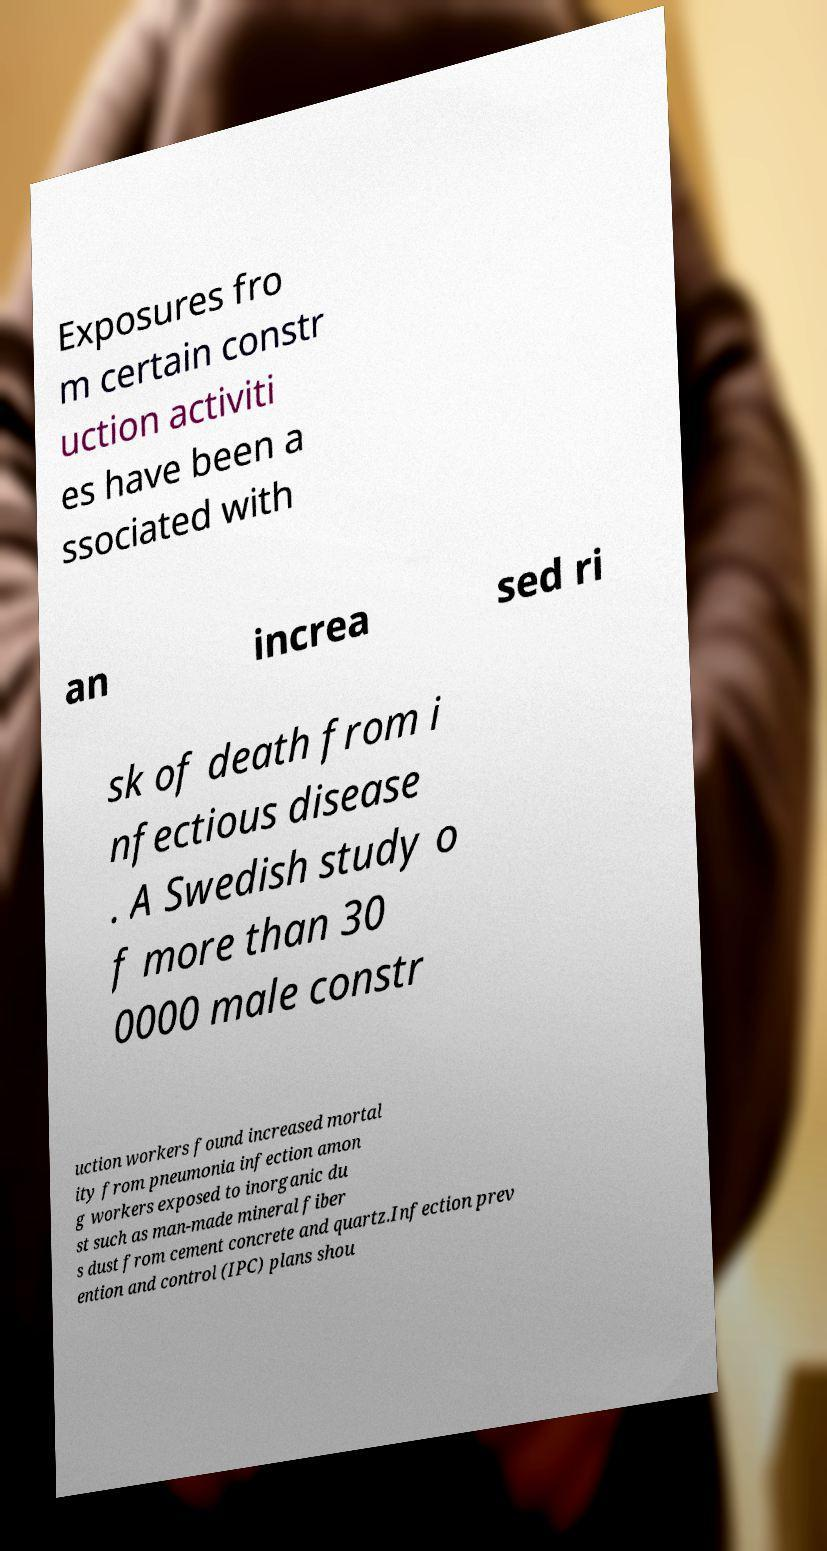Could you extract and type out the text from this image? Exposures fro m certain constr uction activiti es have been a ssociated with an increa sed ri sk of death from i nfectious disease . A Swedish study o f more than 30 0000 male constr uction workers found increased mortal ity from pneumonia infection amon g workers exposed to inorganic du st such as man-made mineral fiber s dust from cement concrete and quartz.Infection prev ention and control (IPC) plans shou 